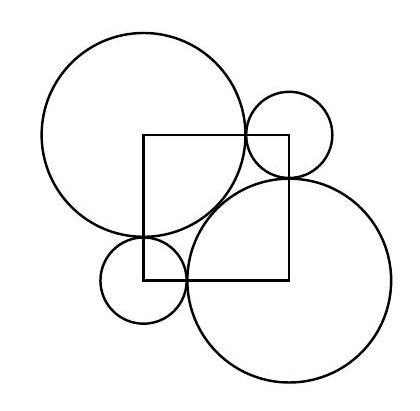Can you describe the geometric principles demonstrated in this image? The image illustrates a geometric arrangement where circles and a square display concepts such as tangency and symmetry. The circles are arranged in a way that each large circle is tangent to both small circles and vice versa, displaying a symmetric setup involving curves and straight lines, which also leads to right-angled triangles that can be analyzed with the Pythagorean theorem. 